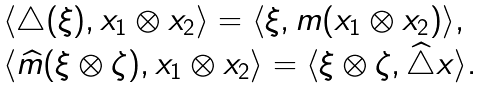<formula> <loc_0><loc_0><loc_500><loc_500>\begin{array} { l } \langle \triangle ( \xi ) , x _ { 1 } \otimes x _ { 2 } \rangle = \langle \xi , m ( x _ { 1 } \otimes x _ { 2 } ) \rangle , \\ \langle \widehat { m } ( \xi \otimes \zeta ) , x _ { 1 } \otimes x _ { 2 } \rangle = \langle \xi \otimes \zeta , \widehat { \triangle } x \rangle . \end{array}</formula> 